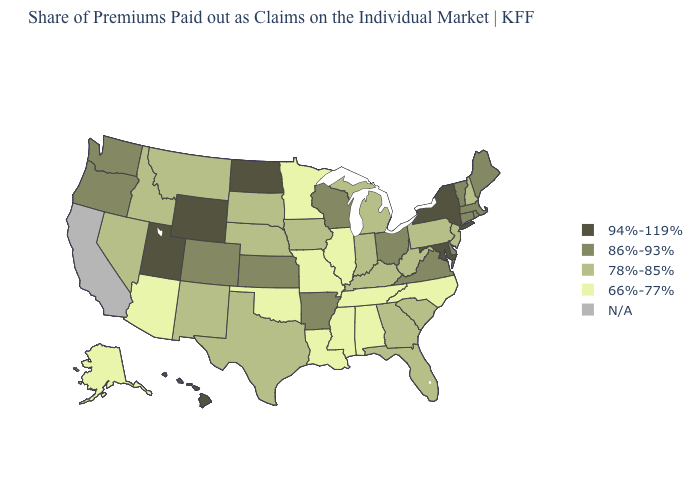Which states have the lowest value in the Northeast?
Keep it brief. New Hampshire, New Jersey, Pennsylvania. What is the value of North Carolina?
Write a very short answer. 66%-77%. Does the map have missing data?
Quick response, please. Yes. What is the highest value in the USA?
Short answer required. 94%-119%. What is the lowest value in the South?
Give a very brief answer. 66%-77%. What is the value of Tennessee?
Keep it brief. 66%-77%. Does the map have missing data?
Keep it brief. Yes. What is the lowest value in states that border Texas?
Give a very brief answer. 66%-77%. What is the highest value in the USA?
Give a very brief answer. 94%-119%. Does Mississippi have the lowest value in the USA?
Short answer required. Yes. Does Oklahoma have the lowest value in the USA?
Answer briefly. Yes. Does New York have the highest value in the Northeast?
Short answer required. Yes. What is the lowest value in the USA?
Short answer required. 66%-77%. 